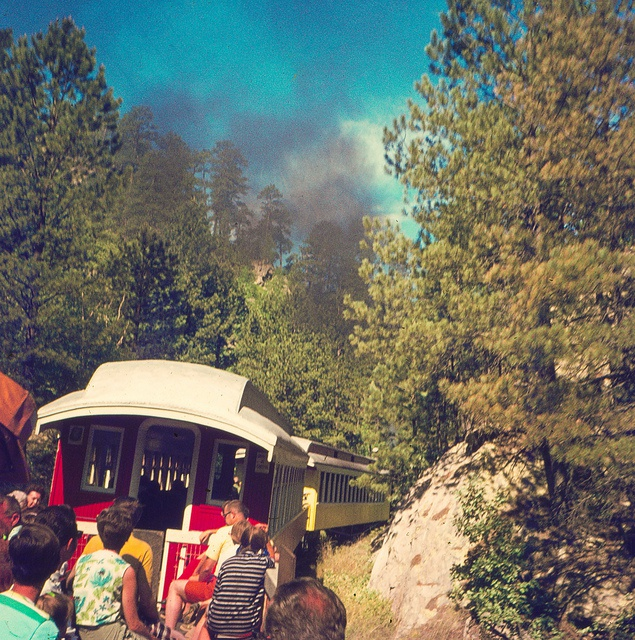Describe the objects in this image and their specific colors. I can see train in teal, black, beige, gray, and navy tones, people in teal, khaki, beige, tan, and black tones, people in teal, gray, black, navy, and brown tones, people in teal, black, aquamarine, and turquoise tones, and people in teal, brown, purple, and black tones in this image. 